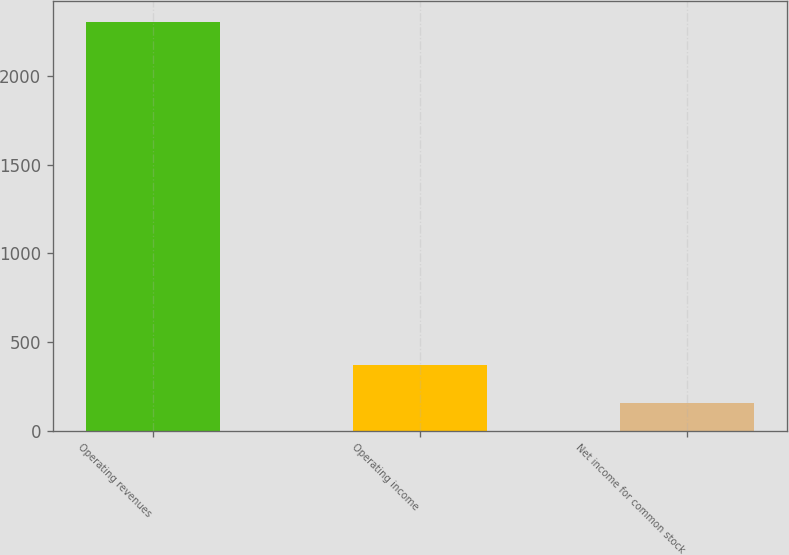Convert chart. <chart><loc_0><loc_0><loc_500><loc_500><bar_chart><fcel>Operating revenues<fcel>Operating income<fcel>Net income for common stock<nl><fcel>2308<fcel>368.5<fcel>153<nl></chart> 